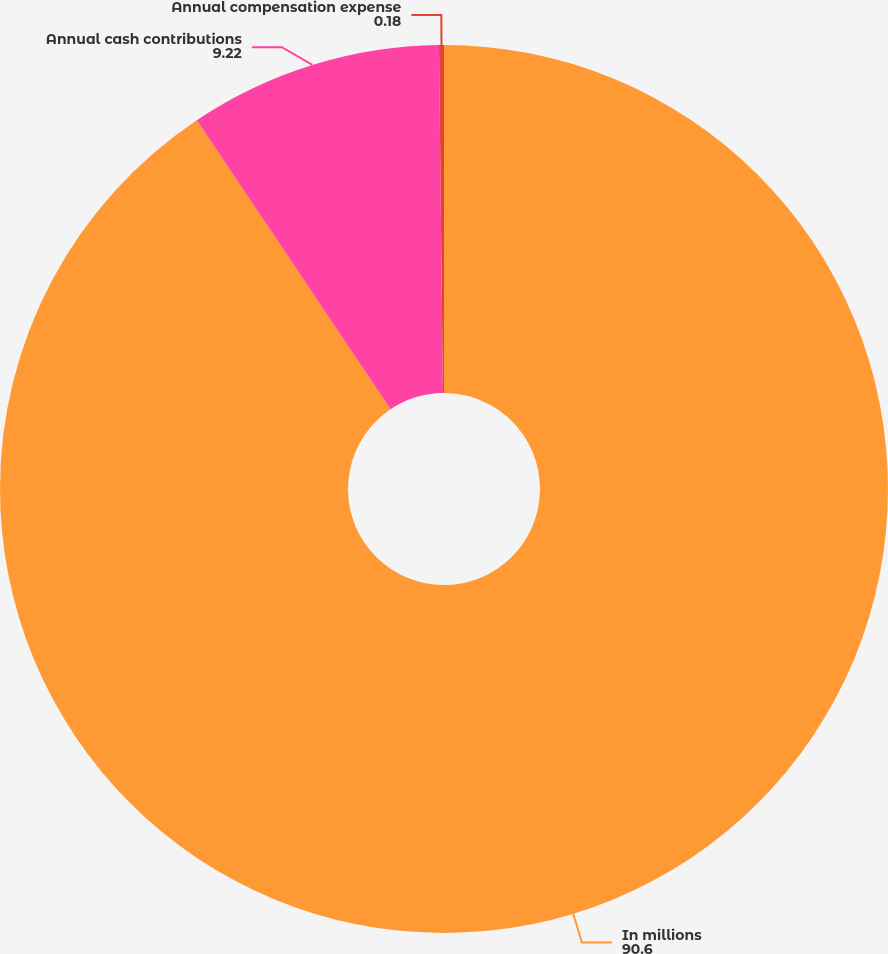Convert chart. <chart><loc_0><loc_0><loc_500><loc_500><pie_chart><fcel>In millions<fcel>Annual cash contributions<fcel>Annual compensation expense<nl><fcel>90.6%<fcel>9.22%<fcel>0.18%<nl></chart> 